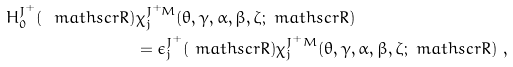<formula> <loc_0><loc_0><loc_500><loc_500>H ^ { J ^ { + } } _ { 0 } ( \ m a t h s c r { R } ) & \chi ^ { J ^ { + } M } _ { j } ( \theta , \gamma , \alpha , \beta , \zeta ; \ m a t h s c r { R } ) \\ & = \epsilon ^ { J ^ { + } } _ { j } ( \ m a t h s c r { R } ) \chi ^ { J ^ { + } M } _ { j } ( \theta , \gamma , \alpha , \beta , \zeta ; \ m a t h s c r { R } ) \ , \\</formula> 